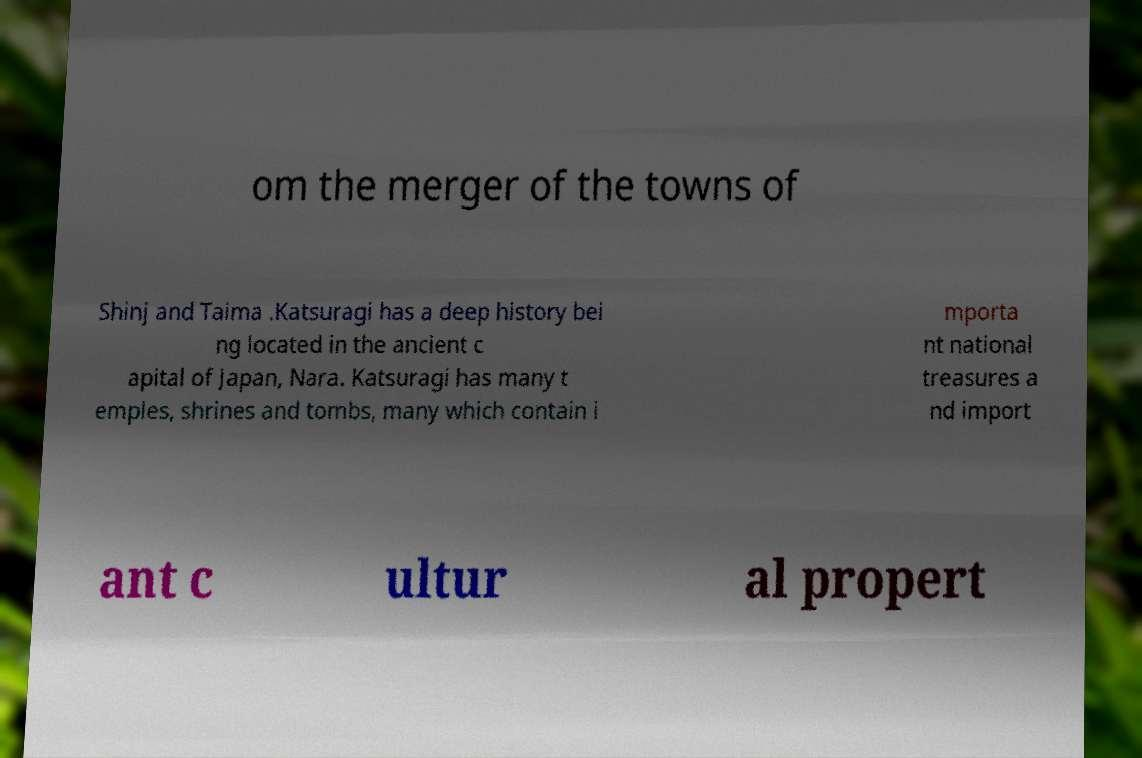Please read and relay the text visible in this image. What does it say? om the merger of the towns of Shinj and Taima .Katsuragi has a deep history bei ng located in the ancient c apital of Japan, Nara. Katsuragi has many t emples, shrines and tombs, many which contain i mporta nt national treasures a nd import ant c ultur al propert 